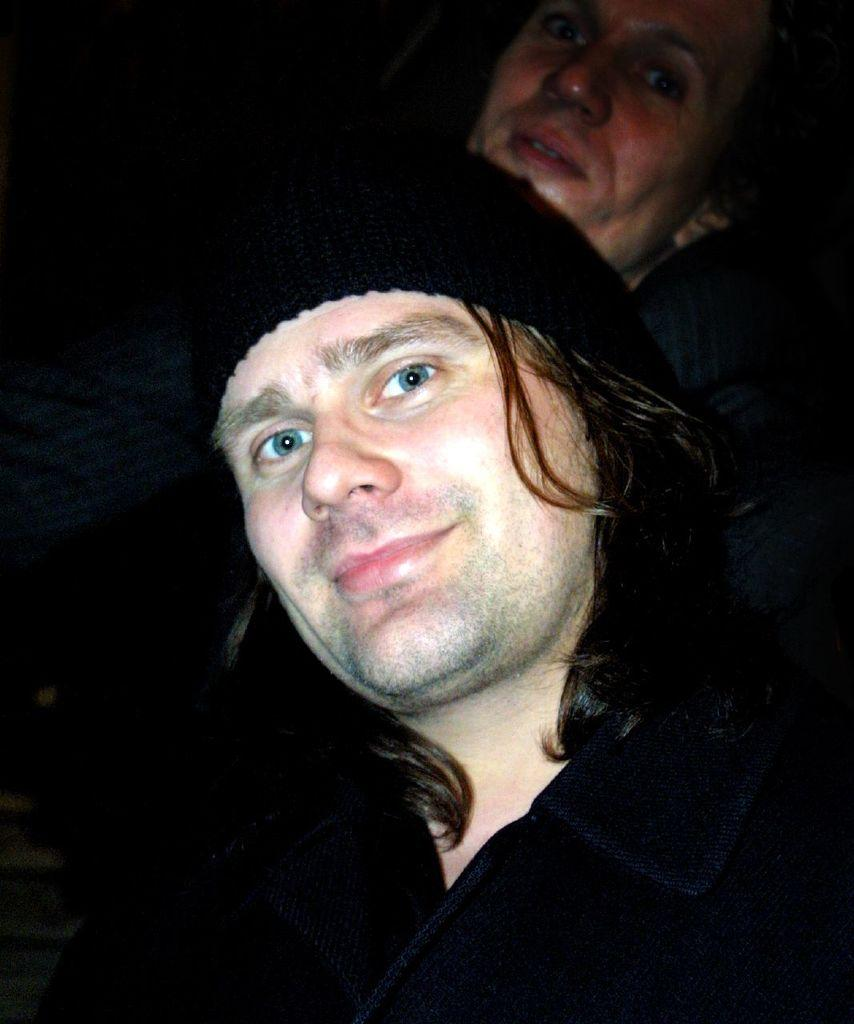How many people are in the image? There are two persons in the image. What color are the clothes worn by the people in the image? Both persons are wearing black color dress. What headgear are the people wearing in the image? Both persons are wearing caps. What are the people in the image doing? The two persons are posing for a photograph. What type of vegetable can be seen hanging from the caps in the image? There is no vegetable present in the image, and nothing is hanging from the caps. 